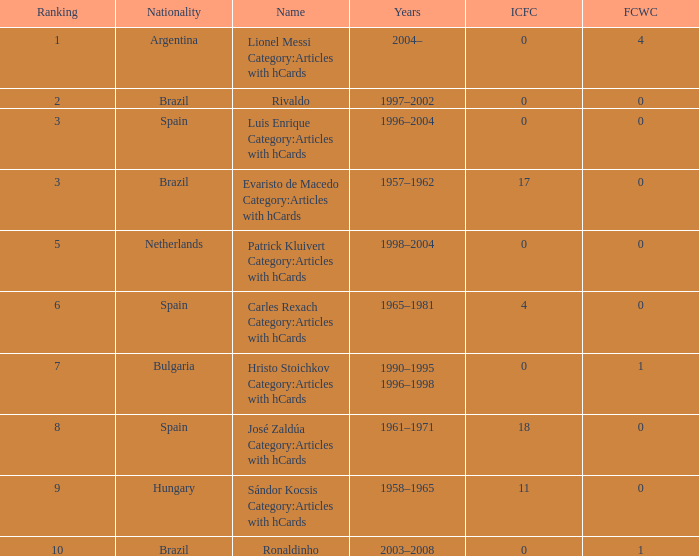What is the highest number of FCWC in the Years of 1958–1965, and an ICFC smaller than 11? None. 